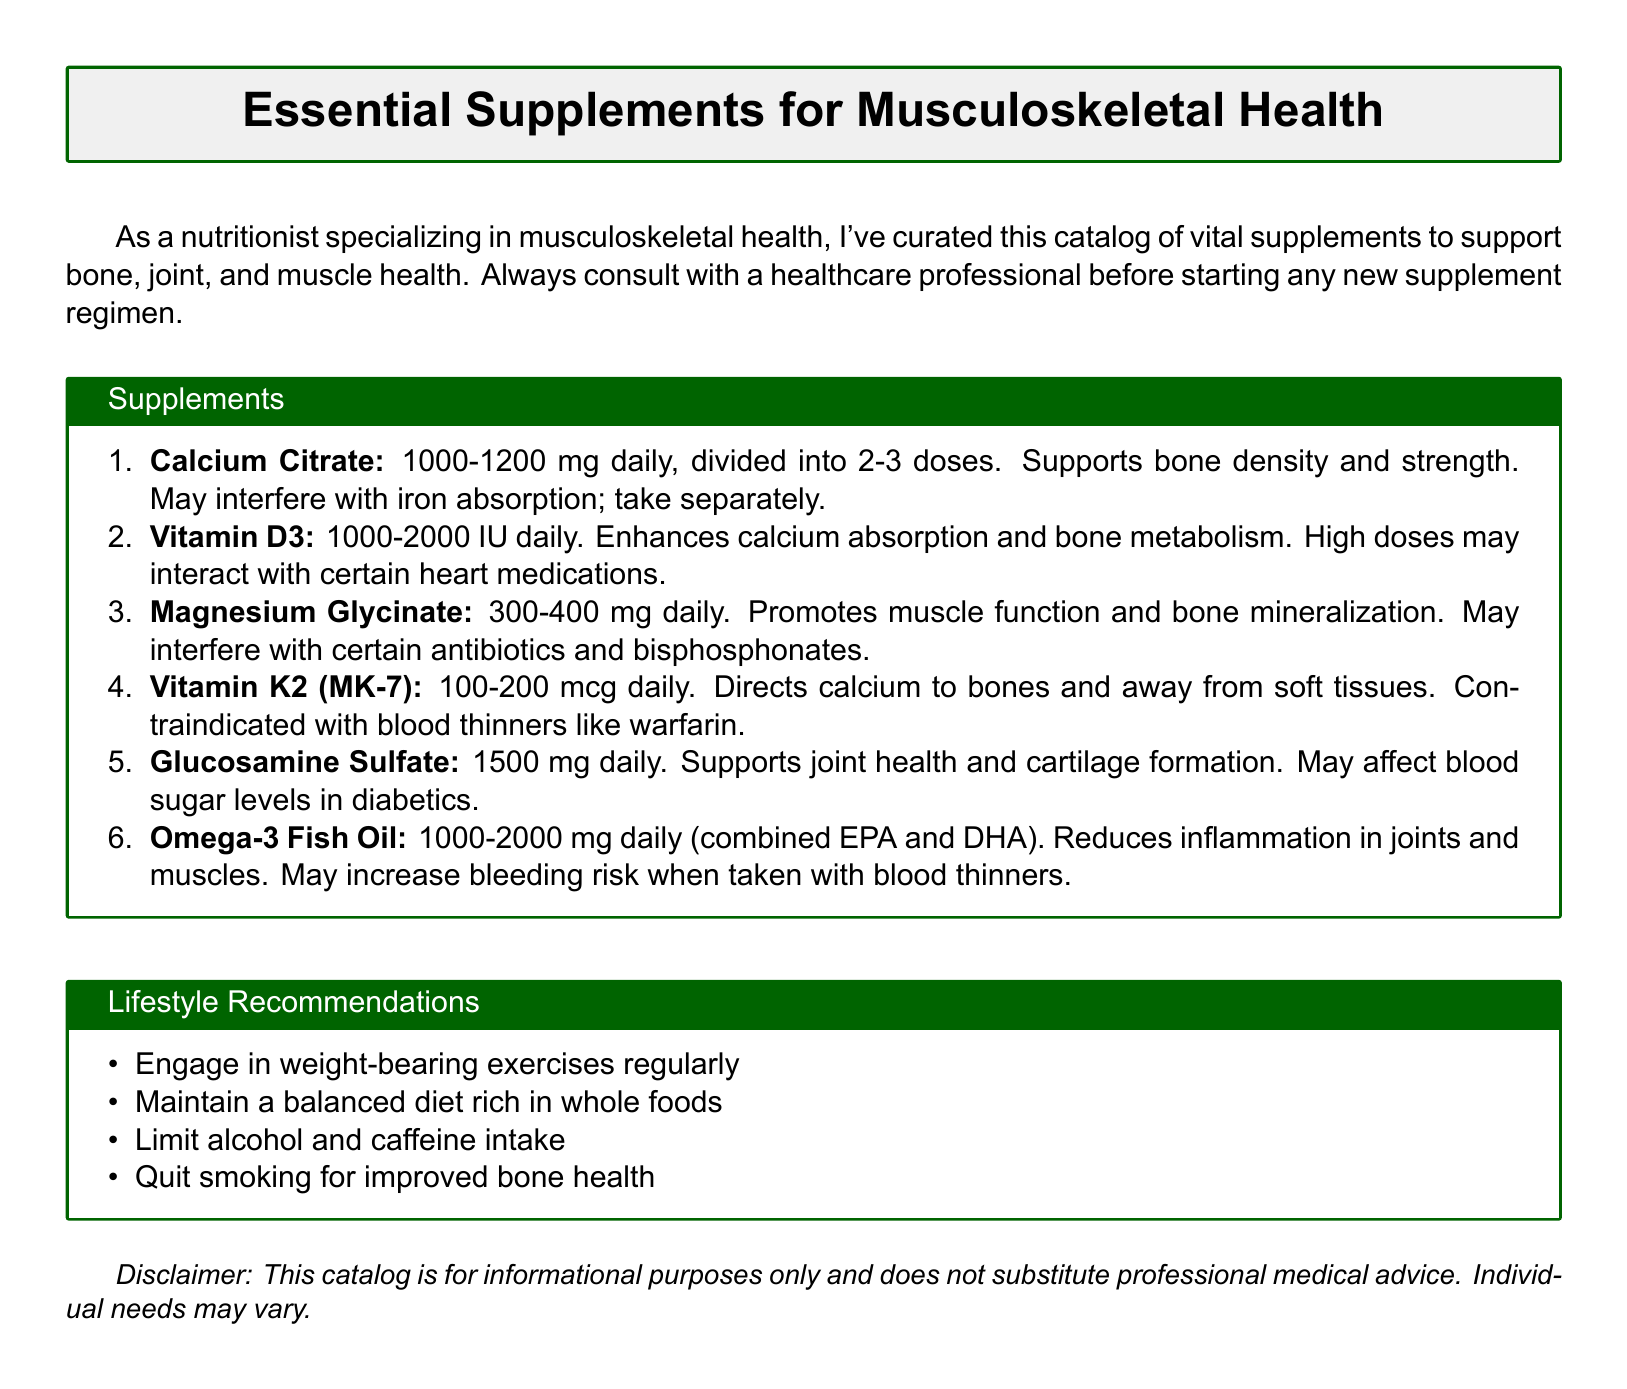what is the recommended dosage of Calcium Citrate? The recommended dosage of Calcium Citrate is 1000-1200 mg daily, divided into 2-3 doses.
Answer: 1000-1200 mg daily, divided into 2-3 doses which supplement supports joint health? The supplement that supports joint health is Glucosamine Sulfate.
Answer: Glucosamine Sulfate what is the daily dosage range for Vitamin D3? The daily dosage range for Vitamin D3 is 1000-2000 IU.
Answer: 1000-2000 IU which supplement is contraindicated with blood thinners? The supplement that is contraindicated with blood thinners is Vitamin K2 (MK-7).
Answer: Vitamin K2 (MK-7) what is the potential interaction of Magnesium Glycinate? Magnesium Glycinate may interfere with certain antibiotics and bisphosphonates.
Answer: Certain antibiotics and bisphosphonates how much Omega-3 Fish Oil should be taken daily? The recommended daily intake of Omega-3 Fish Oil is 1000-2000 mg.
Answer: 1000-2000 mg what is one lifestyle recommendation mentioned in the document? Engaging in weight-bearing exercises regularly is one lifestyle recommendation.
Answer: Engage in weight-bearing exercises regularly what role does Vitamin D3 play in musculoskeletal health? Vitamin D3 enhances calcium absorption and bone metabolism.
Answer: Enhances calcium absorption and bone metabolism how does Glucosamine Sulfate affect blood sugar levels? Glucosamine Sulfate may affect blood sugar levels in diabetics.
Answer: May affect blood sugar levels in diabetics 